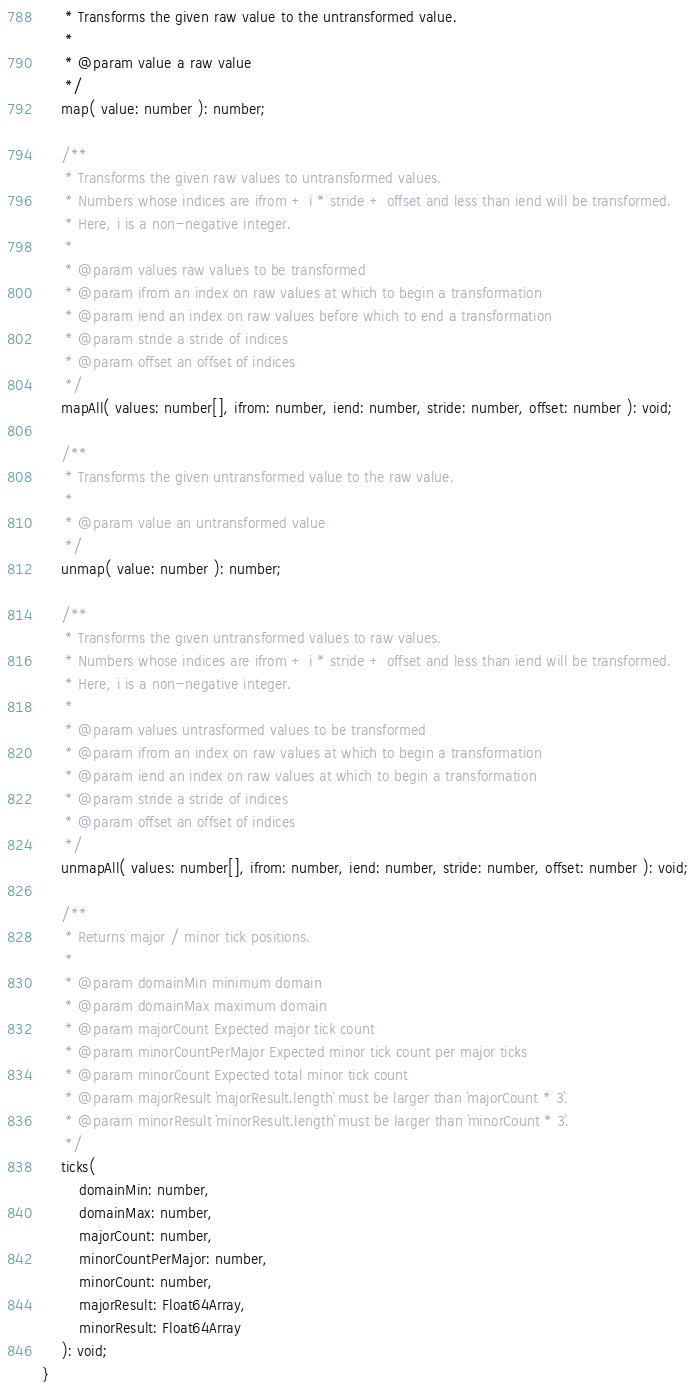<code> <loc_0><loc_0><loc_500><loc_500><_TypeScript_>	 * Transforms the given raw value to the untransformed value.
	 *
	 * @param value a raw value
	 */
	map( value: number ): number;

	/**
	 * Transforms the given raw values to untransformed values.
	 * Numbers whose indices are ifrom + i * stride + offset and less than iend will be transformed.
	 * Here, i is a non-negative integer.
	 *
	 * @param values raw values to be transformed
	 * @param ifrom an index on raw values at which to begin a transformation
	 * @param iend an index on raw values before which to end a transformation
	 * @param stride a stride of indices
	 * @param offset an offset of indices
	 */
	mapAll( values: number[], ifrom: number, iend: number, stride: number, offset: number ): void;

	/**
	 * Transforms the given untransformed value to the raw value.
	 *
	 * @param value an untransformed value
	 */
	unmap( value: number ): number;

	/**
	 * Transforms the given untransformed values to raw values.
	 * Numbers whose indices are ifrom + i * stride + offset and less than iend will be transformed.
	 * Here, i is a non-negative integer.
	 *
	 * @param values untrasformed values to be transformed
	 * @param ifrom an index on raw values at which to begin a transformation
	 * @param iend an index on raw values at which to begin a transformation
	 * @param stride a stride of indices
	 * @param offset an offset of indices
	 */
	unmapAll( values: number[], ifrom: number, iend: number, stride: number, offset: number ): void;

	/**
	 * Returns major / minor tick positions.
	 *
	 * @param domainMin minimum domain
	 * @param domainMax maximum domain
	 * @param majorCount Expected major tick count
	 * @param minorCountPerMajor Expected minor tick count per major ticks
	 * @param minorCount Expected total minor tick count
	 * @param majorResult `majorResult.length` must be larger than `majorCount * 3`.
	 * @param minorResult `minorResult.length` must be larger than `minorCount * 3`.
	 */
	ticks(
		domainMin: number,
		domainMax: number,
		majorCount: number,
		minorCountPerMajor: number,
		minorCount: number,
		majorResult: Float64Array,
		minorResult: Float64Array
	): void;
}
</code> 